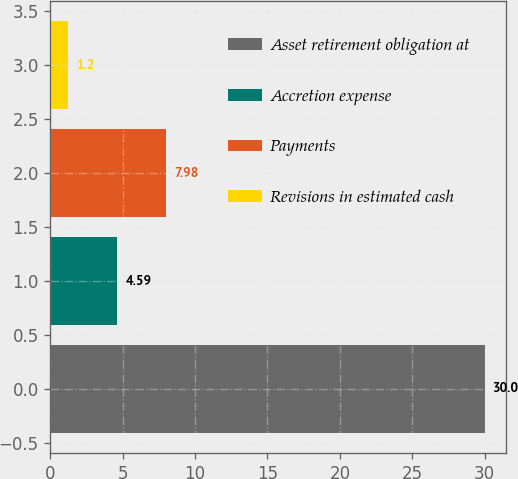Convert chart. <chart><loc_0><loc_0><loc_500><loc_500><bar_chart><fcel>Asset retirement obligation at<fcel>Accretion expense<fcel>Payments<fcel>Revisions in estimated cash<nl><fcel>30<fcel>4.59<fcel>7.98<fcel>1.2<nl></chart> 